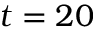<formula> <loc_0><loc_0><loc_500><loc_500>t = 2 0</formula> 